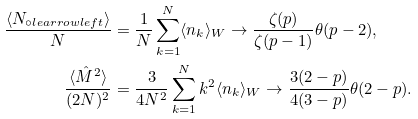<formula> <loc_0><loc_0><loc_500><loc_500>\frac { \langle N _ { \circ l e a r r o w l e f t } \rangle } { N } & = \frac { 1 } { N } \sum _ { k = 1 } ^ { N } \langle n _ { k } \rangle _ { W } \to \frac { \zeta ( p ) } { \zeta ( p - 1 ) } \theta ( p - 2 ) , \\ \frac { \langle \hat { M } ^ { 2 } \rangle } { ( 2 N ) ^ { 2 } } & = \frac { 3 } { 4 N ^ { 2 } } \sum _ { k = 1 } ^ { N } k ^ { 2 } \langle n _ { k } \rangle _ { W } \to \frac { 3 ( 2 - p ) } { 4 ( 3 - p ) } \theta ( 2 - p ) .</formula> 